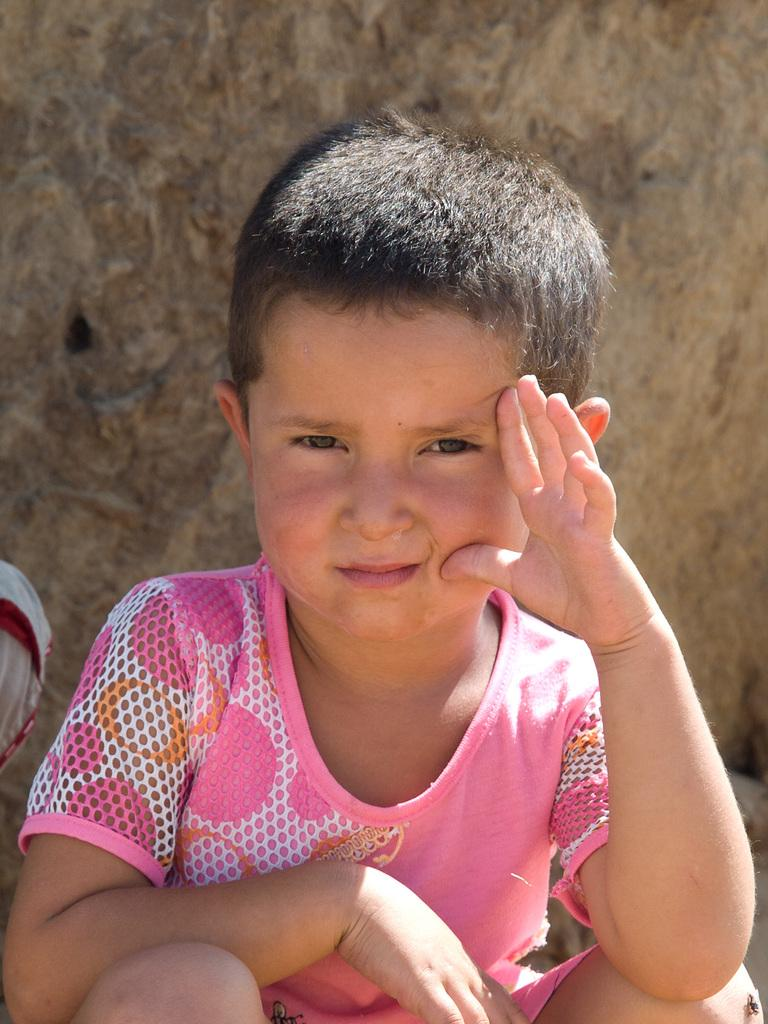What is the main subject of the image? There is a boy sitting in the image. Can you describe the setting of the image? There is a wall in the background of the image. How many balls are being thrown in the image? There are no balls present in the image. What type of pies can be seen on the table in the image? There is no table or pies visible in the image. 